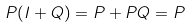Convert formula to latex. <formula><loc_0><loc_0><loc_500><loc_500>P ( I + Q ) = P + P Q = P</formula> 